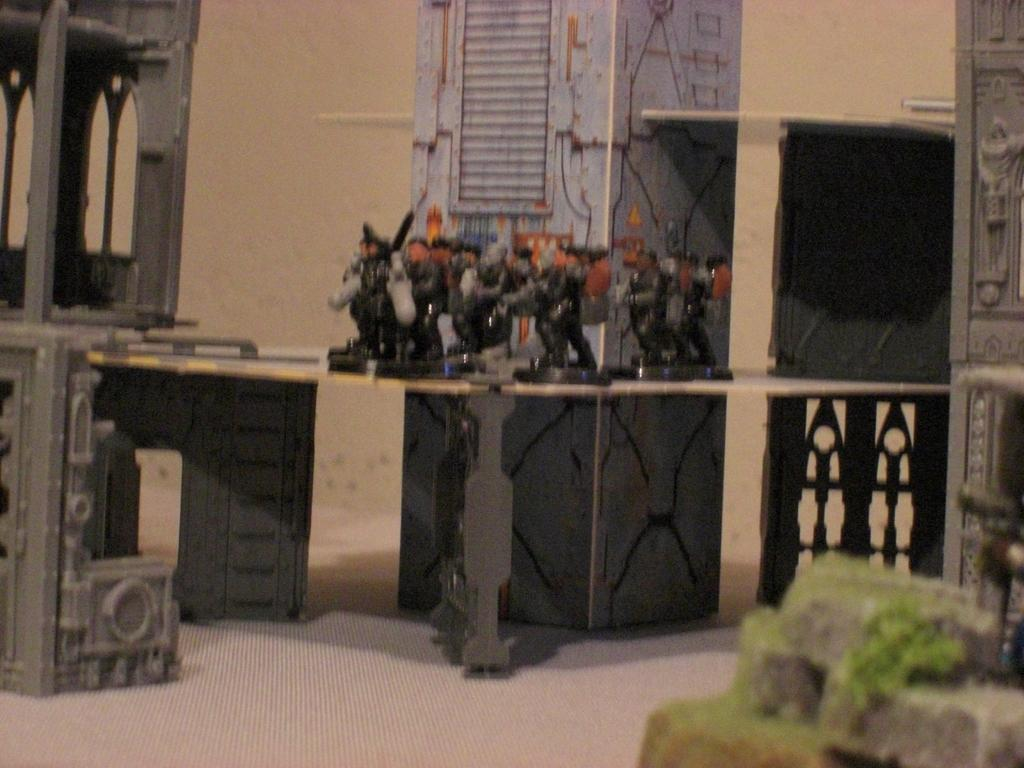What objects can be seen on the table in the image? There are toys arranged on the table in the image. What type of structures are present in the image? There are metal structures in the image. What architectural element can be seen in the image? There is a pillar in the image. What type of barrier is visible in the image? There is a wall in the image. How does the pear contribute to the overall design of the image? There is no pear present in the image, so it cannot contribute to the overall design. 